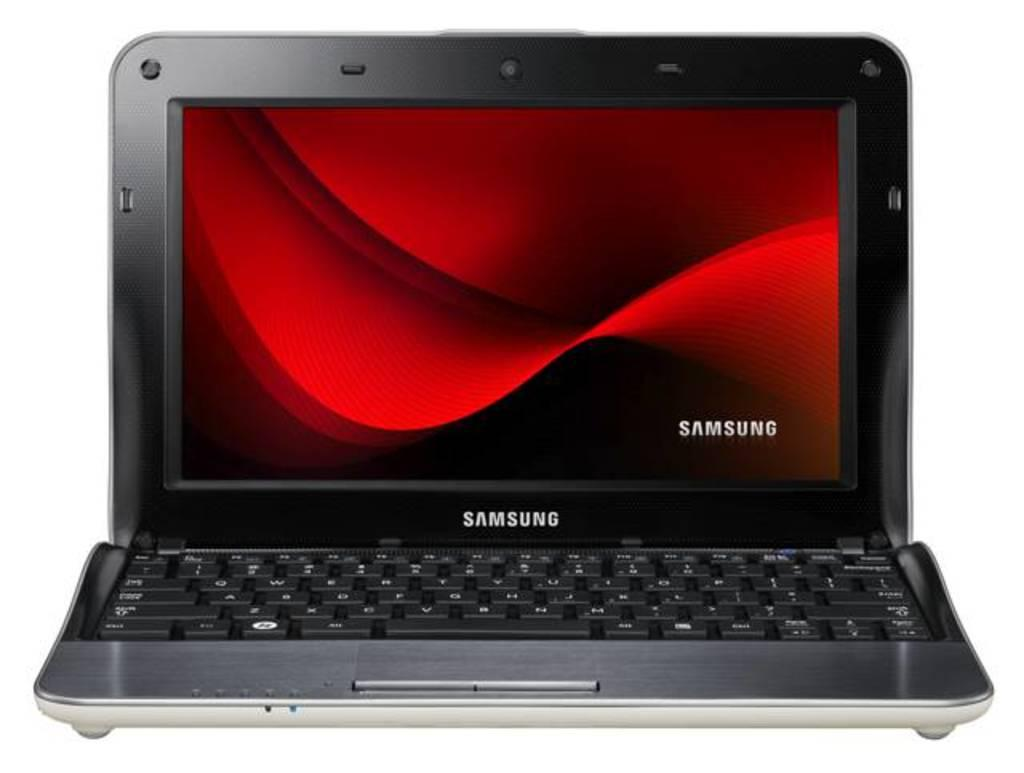<image>
Present a compact description of the photo's key features. A Samsung brand laptop has a red wave shown on the screen. 